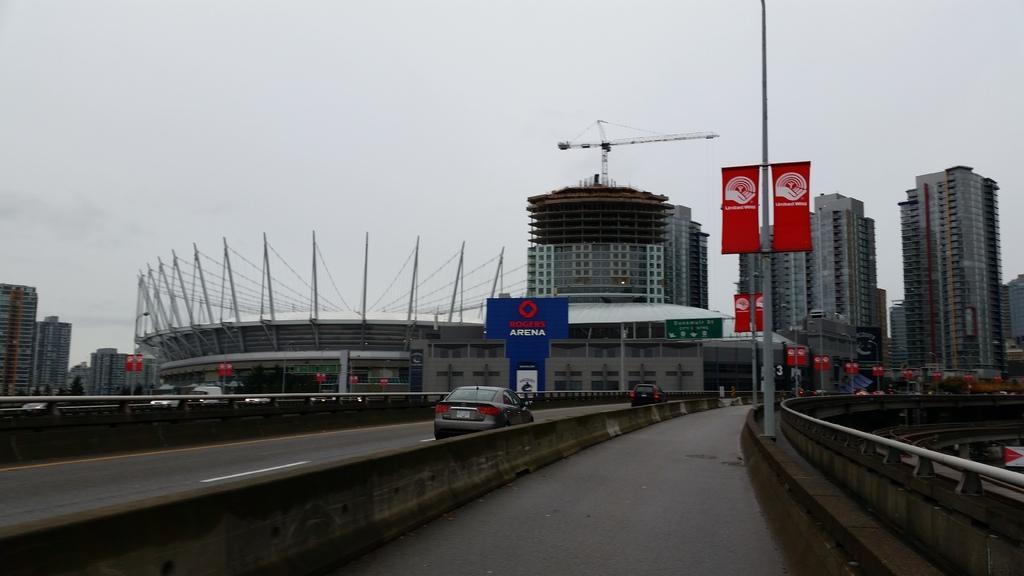In one or two sentences, can you explain what this image depicts? The image is an aerial view of a city. In the foreground we can see roads, banner, pole and a vehicle. In the middle of the picture there are buildings, machinery, poles, banners and other objects. At the top it is sky. 